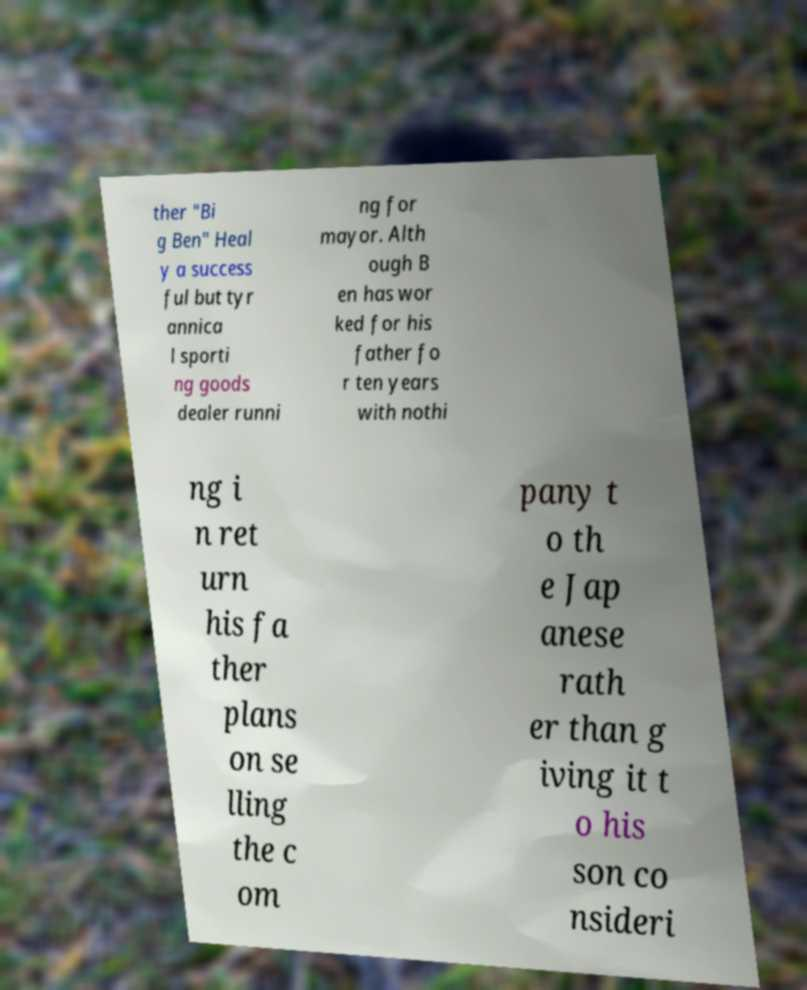Could you assist in decoding the text presented in this image and type it out clearly? ther "Bi g Ben" Heal y a success ful but tyr annica l sporti ng goods dealer runni ng for mayor. Alth ough B en has wor ked for his father fo r ten years with nothi ng i n ret urn his fa ther plans on se lling the c om pany t o th e Jap anese rath er than g iving it t o his son co nsideri 